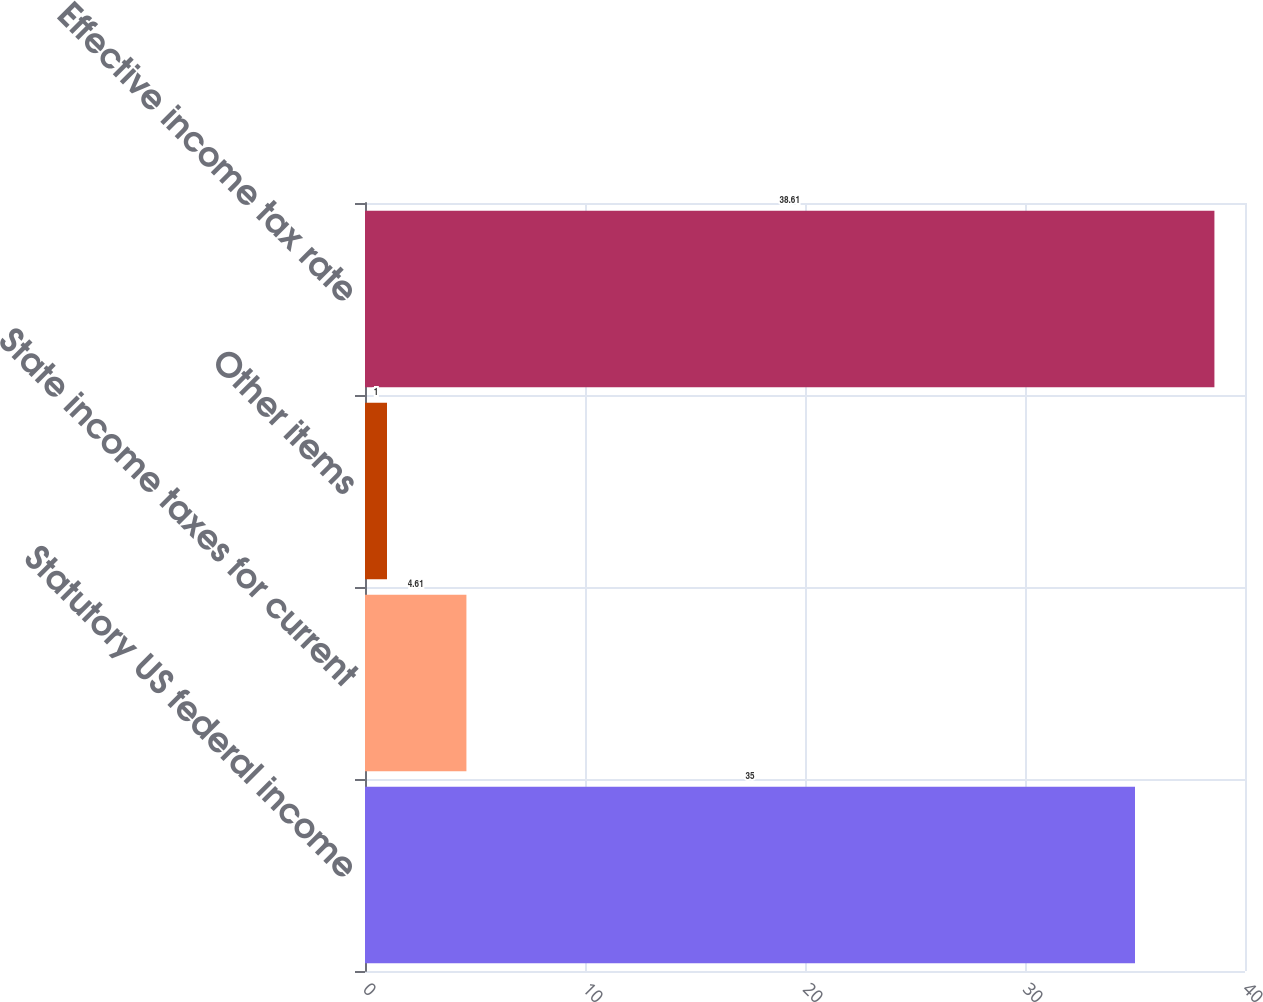<chart> <loc_0><loc_0><loc_500><loc_500><bar_chart><fcel>Statutory US federal income<fcel>State income taxes for current<fcel>Other items<fcel>Effective income tax rate<nl><fcel>35<fcel>4.61<fcel>1<fcel>38.61<nl></chart> 